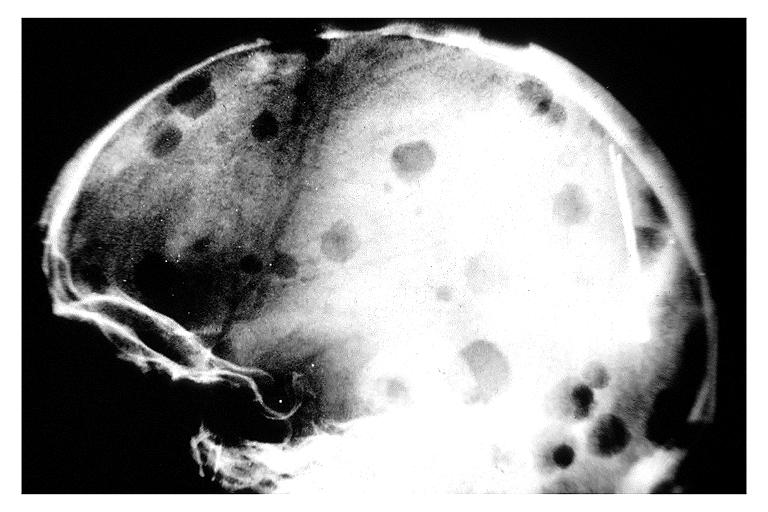what is present?
Answer the question using a single word or phrase. Oral 